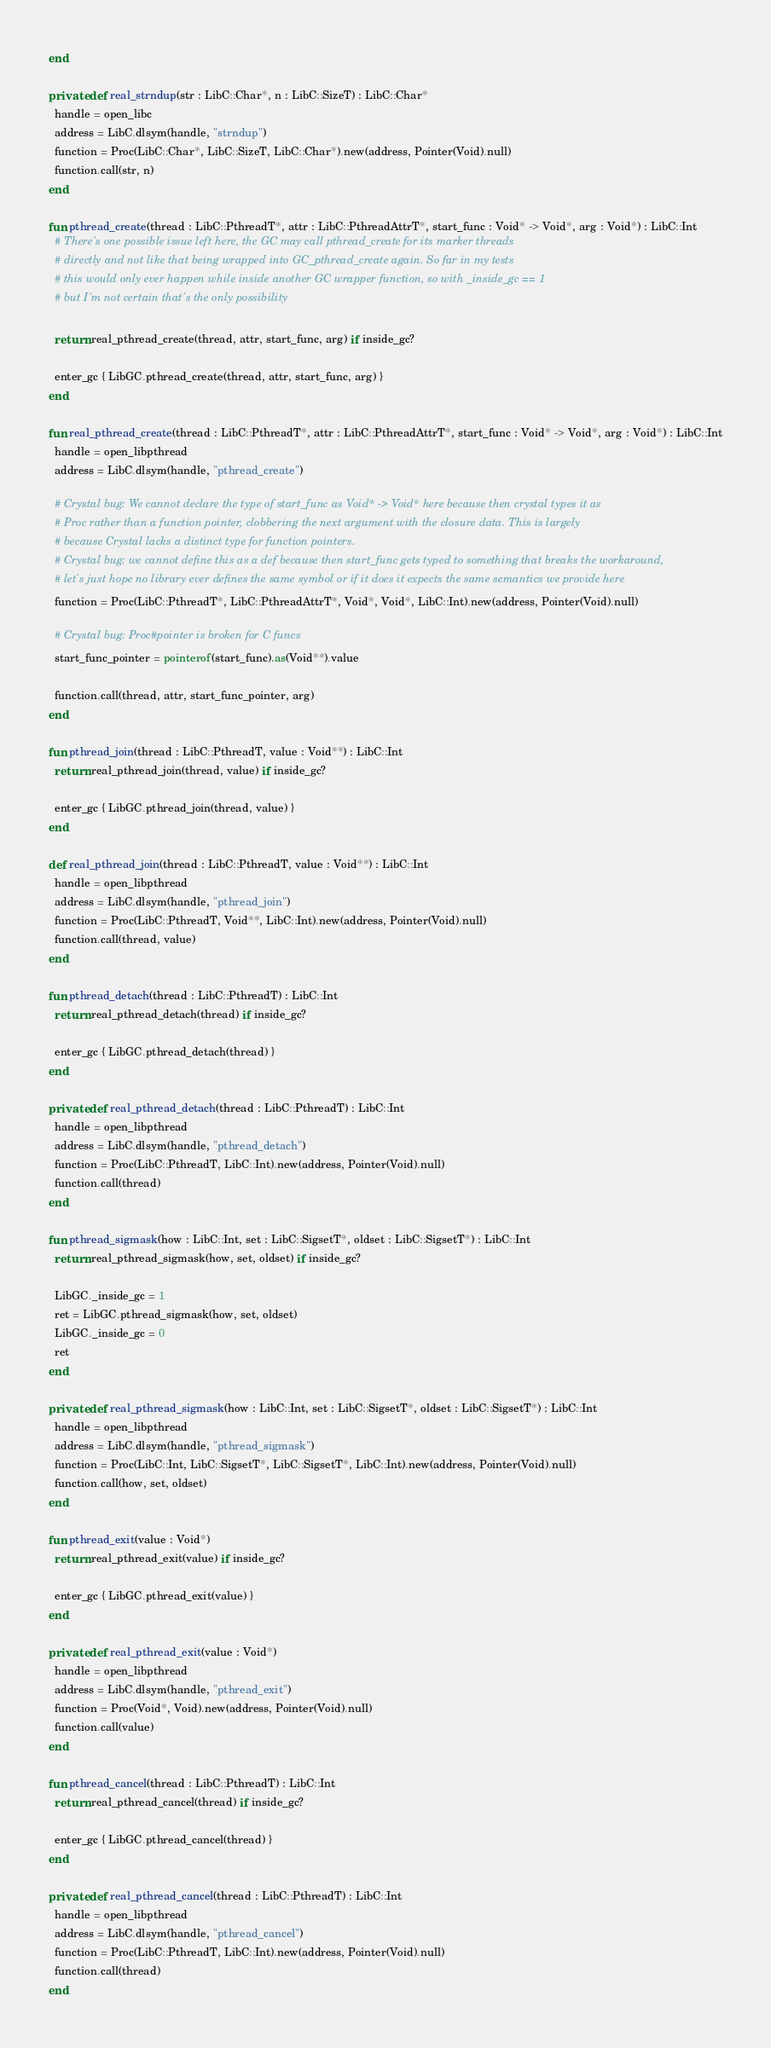Convert code to text. <code><loc_0><loc_0><loc_500><loc_500><_Crystal_>end

private def real_strndup(str : LibC::Char*, n : LibC::SizeT) : LibC::Char*
  handle = open_libc
  address = LibC.dlsym(handle, "strndup")
  function = Proc(LibC::Char*, LibC::SizeT, LibC::Char*).new(address, Pointer(Void).null)
  function.call(str, n)
end

fun pthread_create(thread : LibC::PthreadT*, attr : LibC::PthreadAttrT*, start_func : Void* -> Void*, arg : Void*) : LibC::Int
  # There's one possible issue left here, the GC may call pthread_create for its marker threads
  # directly and not like that being wrapped into GC_pthread_create again. So far in my tests
  # this would only ever happen while inside another GC wrapper function, so with _inside_gc == 1
  # but I'm not certain that's the only possibility

  return real_pthread_create(thread, attr, start_func, arg) if inside_gc?

  enter_gc { LibGC.pthread_create(thread, attr, start_func, arg) }
end

fun real_pthread_create(thread : LibC::PthreadT*, attr : LibC::PthreadAttrT*, start_func : Void* -> Void*, arg : Void*) : LibC::Int
  handle = open_libpthread
  address = LibC.dlsym(handle, "pthread_create")

  # Crystal bug: We cannot declare the type of start_func as Void* -> Void* here because then crystal types it as
  # Proc rather than a function pointer, clobbering the next argument with the closure data. This is largely
  # because Crystal lacks a distinct type for function pointers.
  # Crystal bug: we cannot define this as a def because then start_func gets typed to something that breaks the workaround,
  # let's just hope no library ever defines the same symbol or if it does it expects the same semantics we provide here
  function = Proc(LibC::PthreadT*, LibC::PthreadAttrT*, Void*, Void*, LibC::Int).new(address, Pointer(Void).null)

  # Crystal bug: Proc#pointer is broken for C funcs
  start_func_pointer = pointerof(start_func).as(Void**).value

  function.call(thread, attr, start_func_pointer, arg)
end

fun pthread_join(thread : LibC::PthreadT, value : Void**) : LibC::Int
  return real_pthread_join(thread, value) if inside_gc?

  enter_gc { LibGC.pthread_join(thread, value) }
end

def real_pthread_join(thread : LibC::PthreadT, value : Void**) : LibC::Int
  handle = open_libpthread
  address = LibC.dlsym(handle, "pthread_join")
  function = Proc(LibC::PthreadT, Void**, LibC::Int).new(address, Pointer(Void).null)
  function.call(thread, value)
end

fun pthread_detach(thread : LibC::PthreadT) : LibC::Int
  return real_pthread_detach(thread) if inside_gc?

  enter_gc { LibGC.pthread_detach(thread) }
end

private def real_pthread_detach(thread : LibC::PthreadT) : LibC::Int
  handle = open_libpthread
  address = LibC.dlsym(handle, "pthread_detach")
  function = Proc(LibC::PthreadT, LibC::Int).new(address, Pointer(Void).null)
  function.call(thread)
end

fun pthread_sigmask(how : LibC::Int, set : LibC::SigsetT*, oldset : LibC::SigsetT*) : LibC::Int
  return real_pthread_sigmask(how, set, oldset) if inside_gc?

  LibGC._inside_gc = 1
  ret = LibGC.pthread_sigmask(how, set, oldset)
  LibGC._inside_gc = 0
  ret
end

private def real_pthread_sigmask(how : LibC::Int, set : LibC::SigsetT*, oldset : LibC::SigsetT*) : LibC::Int
  handle = open_libpthread
  address = LibC.dlsym(handle, "pthread_sigmask")
  function = Proc(LibC::Int, LibC::SigsetT*, LibC::SigsetT*, LibC::Int).new(address, Pointer(Void).null)
  function.call(how, set, oldset)
end

fun pthread_exit(value : Void*)
  return real_pthread_exit(value) if inside_gc?

  enter_gc { LibGC.pthread_exit(value) }
end

private def real_pthread_exit(value : Void*)
  handle = open_libpthread
  address = LibC.dlsym(handle, "pthread_exit")
  function = Proc(Void*, Void).new(address, Pointer(Void).null)
  function.call(value)
end

fun pthread_cancel(thread : LibC::PthreadT) : LibC::Int
  return real_pthread_cancel(thread) if inside_gc?

  enter_gc { LibGC.pthread_cancel(thread) }
end

private def real_pthread_cancel(thread : LibC::PthreadT) : LibC::Int
  handle = open_libpthread
  address = LibC.dlsym(handle, "pthread_cancel")
  function = Proc(LibC::PthreadT, LibC::Int).new(address, Pointer(Void).null)
  function.call(thread)
end
</code> 